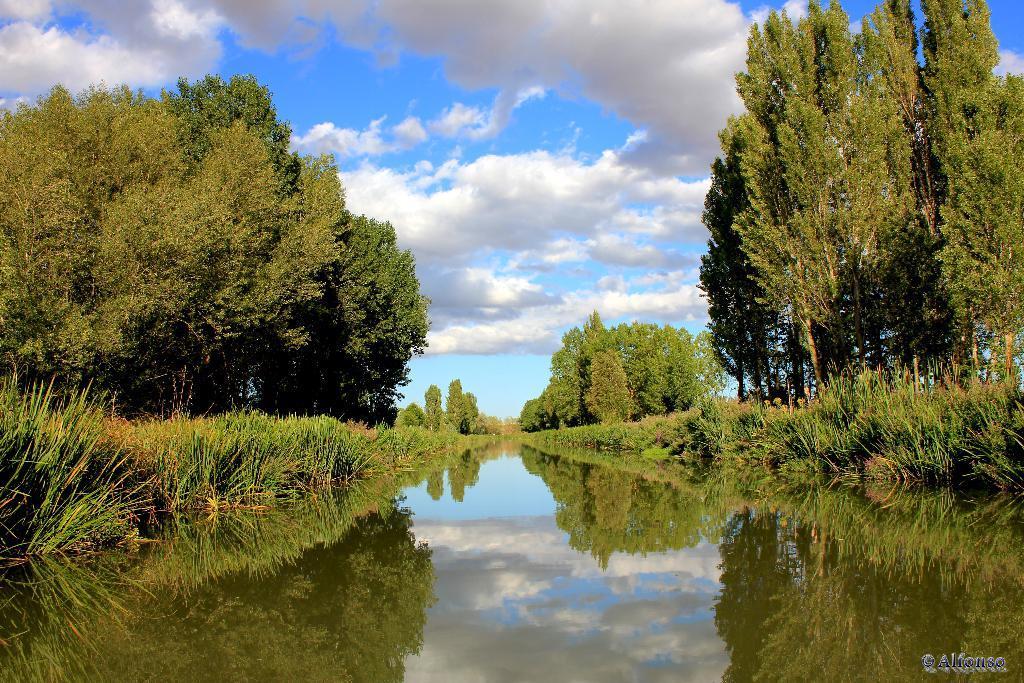In one or two sentences, can you explain what this image depicts? We can see water,grass,trees and sky with clouds. In the bottom right side of the image we can see text. 